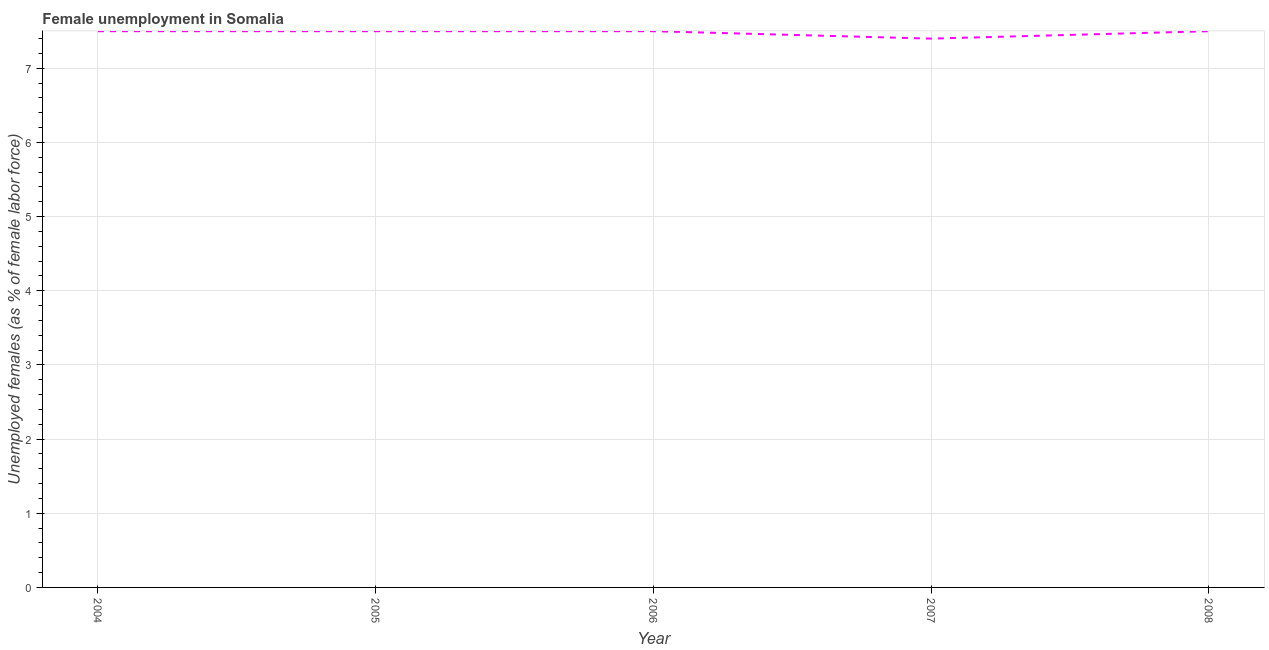What is the unemployed females population in 2005?
Offer a terse response. 7.5. Across all years, what is the minimum unemployed females population?
Keep it short and to the point. 7.4. In which year was the unemployed females population maximum?
Offer a very short reply. 2004. In which year was the unemployed females population minimum?
Provide a short and direct response. 2007. What is the sum of the unemployed females population?
Your response must be concise. 37.4. What is the difference between the unemployed females population in 2006 and 2007?
Make the answer very short. 0.1. What is the average unemployed females population per year?
Offer a very short reply. 7.48. What is the ratio of the unemployed females population in 2007 to that in 2008?
Make the answer very short. 0.99. Is the unemployed females population in 2004 less than that in 2008?
Your answer should be very brief. No. What is the difference between the highest and the second highest unemployed females population?
Offer a terse response. 0. Is the sum of the unemployed females population in 2004 and 2008 greater than the maximum unemployed females population across all years?
Your answer should be compact. Yes. What is the difference between the highest and the lowest unemployed females population?
Your answer should be very brief. 0.1. In how many years, is the unemployed females population greater than the average unemployed females population taken over all years?
Your answer should be very brief. 4. Does the unemployed females population monotonically increase over the years?
Make the answer very short. No. Are the values on the major ticks of Y-axis written in scientific E-notation?
Your response must be concise. No. Does the graph contain grids?
Ensure brevity in your answer.  Yes. What is the title of the graph?
Provide a short and direct response. Female unemployment in Somalia. What is the label or title of the X-axis?
Offer a terse response. Year. What is the label or title of the Y-axis?
Give a very brief answer. Unemployed females (as % of female labor force). What is the Unemployed females (as % of female labor force) in 2005?
Ensure brevity in your answer.  7.5. What is the Unemployed females (as % of female labor force) of 2007?
Provide a succinct answer. 7.4. What is the difference between the Unemployed females (as % of female labor force) in 2004 and 2005?
Provide a succinct answer. 0. What is the difference between the Unemployed females (as % of female labor force) in 2004 and 2006?
Your response must be concise. 0. What is the difference between the Unemployed females (as % of female labor force) in 2004 and 2007?
Give a very brief answer. 0.1. What is the difference between the Unemployed females (as % of female labor force) in 2005 and 2006?
Offer a very short reply. 0. What is the difference between the Unemployed females (as % of female labor force) in 2005 and 2007?
Keep it short and to the point. 0.1. What is the difference between the Unemployed females (as % of female labor force) in 2006 and 2007?
Offer a terse response. 0.1. What is the difference between the Unemployed females (as % of female labor force) in 2006 and 2008?
Make the answer very short. 0. What is the ratio of the Unemployed females (as % of female labor force) in 2004 to that in 2006?
Your answer should be compact. 1. What is the ratio of the Unemployed females (as % of female labor force) in 2004 to that in 2008?
Offer a very short reply. 1. What is the ratio of the Unemployed females (as % of female labor force) in 2006 to that in 2007?
Ensure brevity in your answer.  1.01. What is the ratio of the Unemployed females (as % of female labor force) in 2006 to that in 2008?
Your response must be concise. 1. 